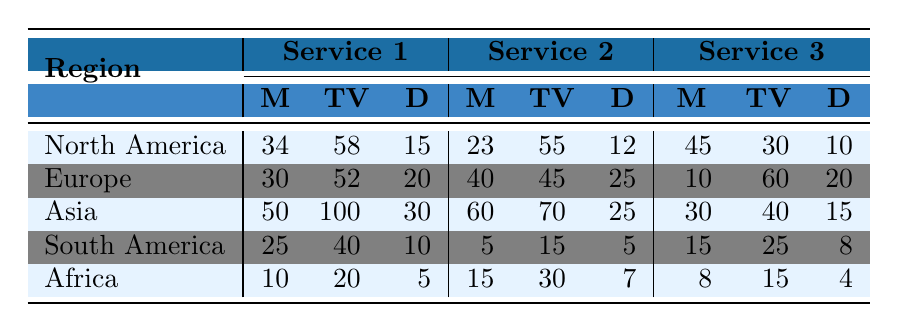What is the number of documentaries available on Netflix in North America? According to the table, Netflix in North America has 15 documentaries listed in the row for that region.
Answer: 15 Which region has the highest number of TV shows on Tencent Video? The table shows that Tencent Video is in Asia with 100 TV shows, which is the highest number.
Answer: Asia How many movies are available across all services in Europe? For Europe, the movies are summed as follows: Netflix (30) + Amazon Prime Video (40) + BBC iPlayer (10) = 80.
Answer: 80 Is there a service in South America with more documentaries than Globoplay? Globoplay has 5 documentaries, while Netflix has 10 and Amazon Prime Video has 8; therefore, both Netflix and Amazon Prime Video offer more documentaries.
Answer: Yes What is the average number of movies available on Disney+ and Hulu? The total number of movies on Disney+ is 45 and on Hulu is 23. Their average is (45 + 23) / 2 = 34.
Answer: 34 How many more TV shows does iQIYI have compared to Disney+ Hotstar? iQIYI has 70 TV shows, whereas Disney+ Hotstar has 40 TV shows. The difference is 70 - 40 = 30.
Answer: 30 Which streaming service has the least number of documentaries in Africa? In Africa, the services have the following documentaries: Showmax (5), Netflix (7), and Amazon Prime Video (4). The service with the least is Amazon Prime Video with 4 documentaries.
Answer: Amazon Prime Video Calculate the total number of TV shows available in Asia across all listed services. The total number of TV shows in Asia is the sum of Tencent Video (100), iQIYI (70), and Disney+ Hotstar (40), which equals 100 + 70 + 40 = 210.
Answer: 210 Is the total number of movies on Netflix in North America higher than in South America? In North America, Netflix has 34 movies, and in South America, Netflix has 25 movies. Since 34 is greater than 25, the answer is yes.
Answer: Yes Which service in Europe has the most documentaries, and how many? In Europe, Amazon Prime Video has 25 documentaries, which is the most compared to Netflix (20) and BBC iPlayer (20).
Answer: Amazon Prime Video, 25 